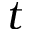Convert formula to latex. <formula><loc_0><loc_0><loc_500><loc_500>t</formula> 